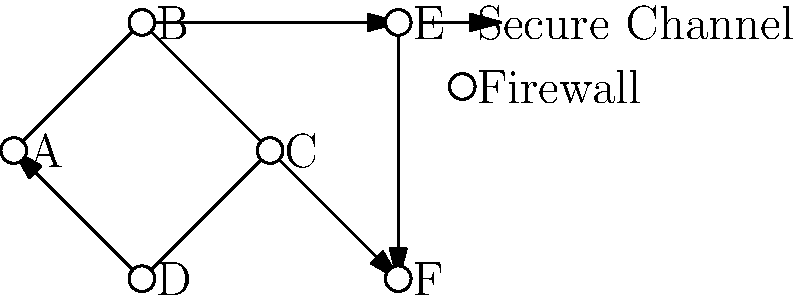In the given network topology diagram for secure diplomatic communications, which node represents the most critical point of failure that could potentially isolate the diplomatic mission from its home country's network? To determine the most critical point of failure in this network topology, we need to analyze the connections and their importance:

1. Node A is connected to B, C, and D, forming a local network.
2. Node B is connected to A and E, providing a link to an external network.
3. Node C is connected to A and F, providing another link to an external network.
4. Node D is only connected to A, making it less critical for overall connectivity.
5. Nodes E and F are connected to each other and to B and C respectively, representing external networks or relay points.

The most critical point of failure would be the node that, if compromised, would cut off the local diplomatic network (A, B, C, D) from both external connections (E and F).

In this case, Node A is the most critical point. If Node A fails:
- The local network loses its central hub.
- Both external connections (through B to E and C to F) become inaccessible to the rest of the local network.
- The diplomatic mission would be completely isolated from its home country's network.

While the loss of B or C would remove one external connection, the other would still be available through the remaining node. Therefore, Node A represents the single point of failure that could potentially isolate the entire diplomatic mission's network.
Answer: Node A 